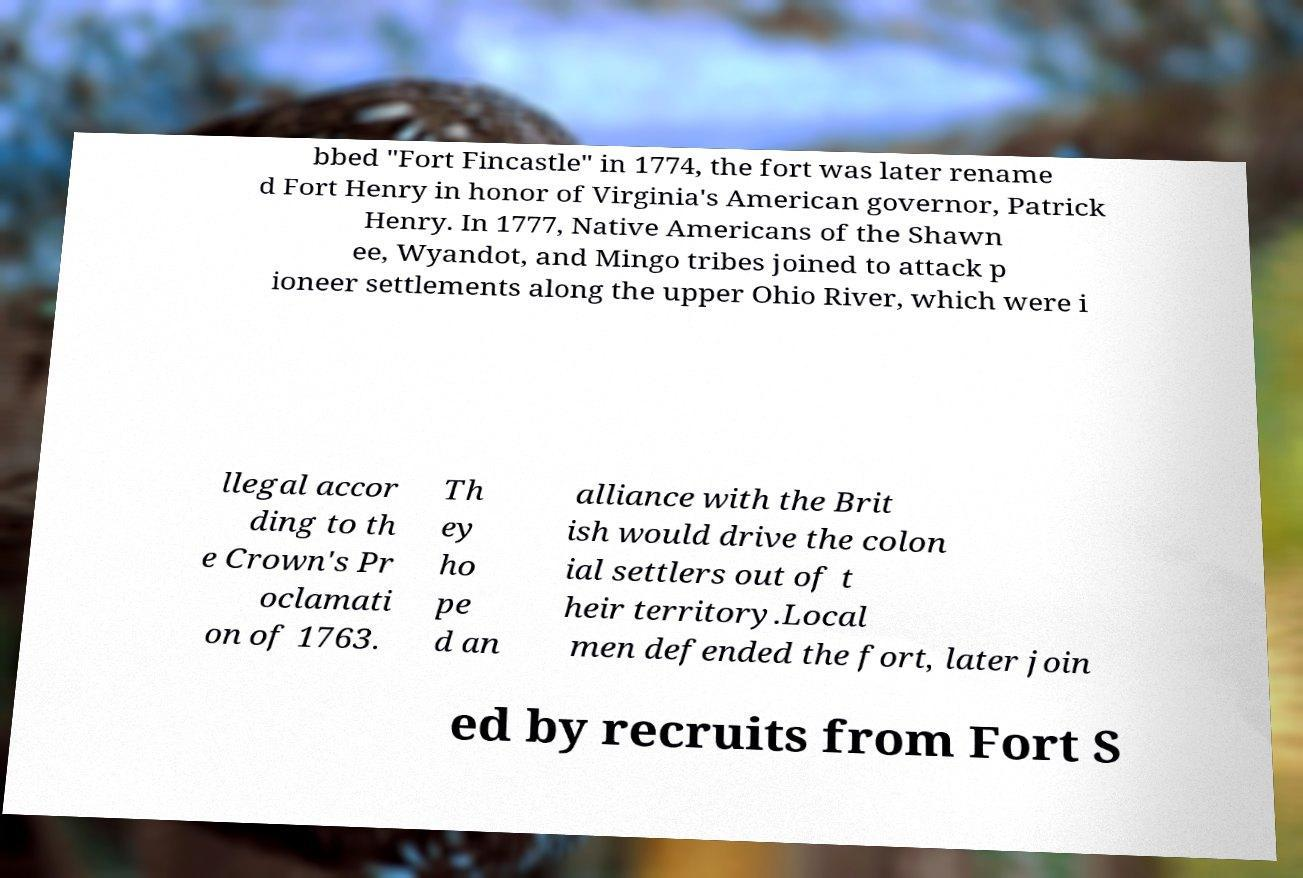There's text embedded in this image that I need extracted. Can you transcribe it verbatim? bbed "Fort Fincastle" in 1774, the fort was later rename d Fort Henry in honor of Virginia's American governor, Patrick Henry. In 1777, Native Americans of the Shawn ee, Wyandot, and Mingo tribes joined to attack p ioneer settlements along the upper Ohio River, which were i llegal accor ding to th e Crown's Pr oclamati on of 1763. Th ey ho pe d an alliance with the Brit ish would drive the colon ial settlers out of t heir territory.Local men defended the fort, later join ed by recruits from Fort S 